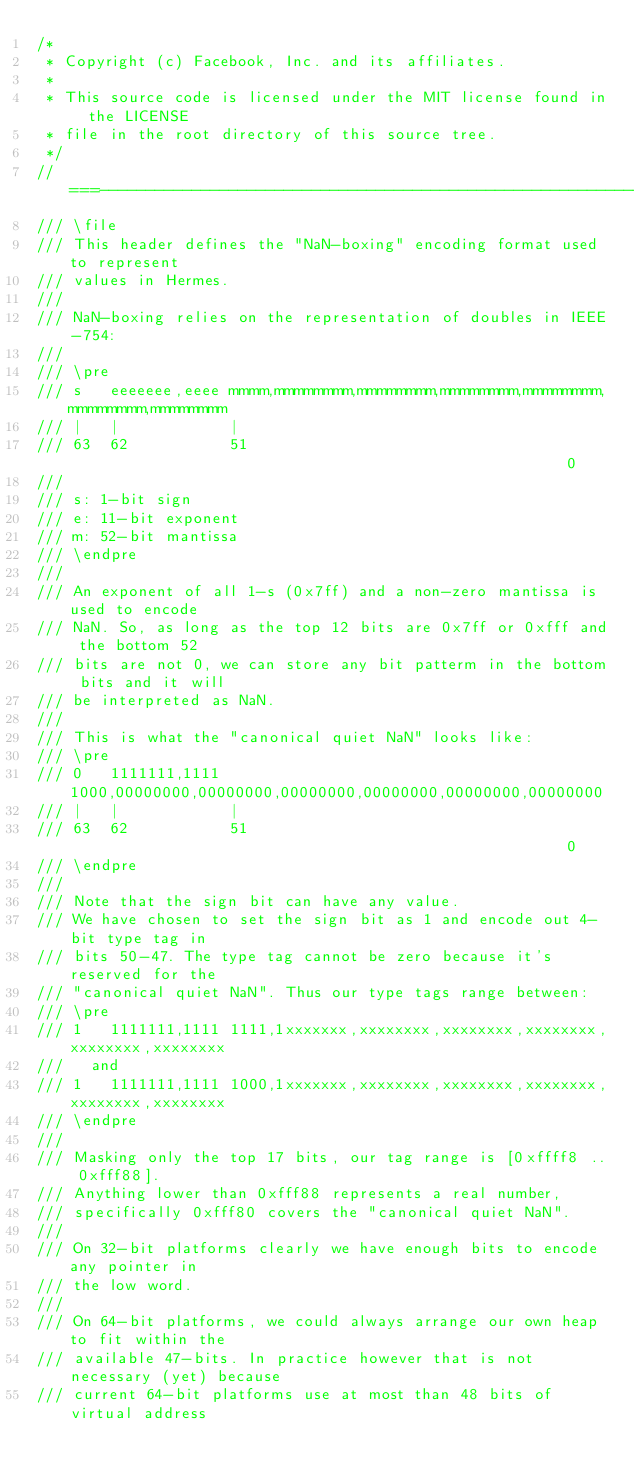Convert code to text. <code><loc_0><loc_0><loc_500><loc_500><_C_>/*
 * Copyright (c) Facebook, Inc. and its affiliates.
 *
 * This source code is licensed under the MIT license found in the LICENSE
 * file in the root directory of this source tree.
 */
//===----------------------------------------------------------------------===//
/// \file
/// This header defines the "NaN-boxing" encoding format used to represent
/// values in Hermes.
///
/// NaN-boxing relies on the representation of doubles in IEEE-754:
///
/// \pre
/// s   eeeeeee,eeee mmmm,mmmmmmmm,mmmmmmmm,mmmmmmmm,mmmmmmmm,mmmmmmmm,mmmmmmmm
/// |   |            |
/// 63  62           51                                                       0
///
/// s: 1-bit sign
/// e: 11-bit exponent
/// m: 52-bit mantissa
/// \endpre
///
/// An exponent of all 1-s (0x7ff) and a non-zero mantissa is used to encode
/// NaN. So, as long as the top 12 bits are 0x7ff or 0xfff and the bottom 52
/// bits are not 0, we can store any bit patterm in the bottom bits and it will
/// be interpreted as NaN.
///
/// This is what the "canonical quiet NaN" looks like:
/// \pre
/// 0   1111111,1111 1000,00000000,00000000,00000000,00000000,00000000,00000000
/// |   |            |
/// 63  62           51                                                       0
/// \endpre
///
/// Note that the sign bit can have any value.
/// We have chosen to set the sign bit as 1 and encode out 4-bit type tag in
/// bits 50-47. The type tag cannot be zero because it's reserved for the
/// "canonical quiet NaN". Thus our type tags range between:
/// \pre
/// 1   1111111,1111 1111,1xxxxxxx,xxxxxxxx,xxxxxxxx,xxxxxxxx,xxxxxxxx,xxxxxxxx
///   and
/// 1   1111111,1111 1000,1xxxxxxx,xxxxxxxx,xxxxxxxx,xxxxxxxx,xxxxxxxx,xxxxxxxx
/// \endpre
///
/// Masking only the top 17 bits, our tag range is [0xffff8 .. 0xfff88].
/// Anything lower than 0xfff88 represents a real number,
/// specifically 0xfff80 covers the "canonical quiet NaN".
///
/// On 32-bit platforms clearly we have enough bits to encode any pointer in
/// the low word.
///
/// On 64-bit platforms, we could always arrange our own heap to fit within the
/// available 47-bits. In practice however that is not necessary (yet) because
/// current 64-bit platforms use at most than 48 bits of virtual address</code> 